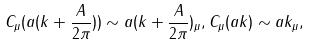<formula> <loc_0><loc_0><loc_500><loc_500>C _ { \mu } ( a ( k + \frac { A } { 2 \pi } ) ) \sim a ( k + \frac { A } { 2 \pi } ) _ { \mu } , C _ { \mu } ( a k ) \sim a k _ { \mu } ,</formula> 